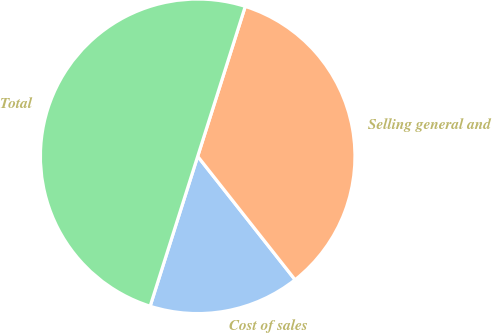Convert chart to OTSL. <chart><loc_0><loc_0><loc_500><loc_500><pie_chart><fcel>Cost of sales<fcel>Selling general and<fcel>Total<nl><fcel>15.52%<fcel>34.48%<fcel>50.0%<nl></chart> 